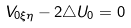Convert formula to latex. <formula><loc_0><loc_0><loc_500><loc_500>V _ { 0 \xi \eta } - 2 \triangle U _ { 0 } = 0</formula> 